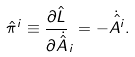Convert formula to latex. <formula><loc_0><loc_0><loc_500><loc_500>\hat { \pi } ^ { i } \equiv \frac { \partial \hat { L } } { \partial \dot { \hat { A } } } _ { i } = - \dot { \hat { A ^ { i } } } .</formula> 